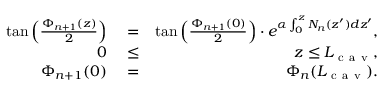Convert formula to latex. <formula><loc_0><loc_0><loc_500><loc_500>\begin{array} { r l r } { \tan \left ( \frac { \Phi _ { n + 1 } ( z ) } { 2 } \right ) } & = } & { \tan \left ( \frac { \Phi _ { n + 1 } ( 0 ) } { 2 } \right ) \cdot e ^ { \alpha \int _ { 0 } ^ { z } N _ { n } ( z ^ { \prime } ) d z ^ { \prime } } , } \\ { 0 } & \leq } & { z \leq L _ { c a v } , } \\ { \Phi _ { n + 1 } ( 0 ) } & = } & { \Phi _ { n } ( L _ { c a v } ) . } \end{array}</formula> 